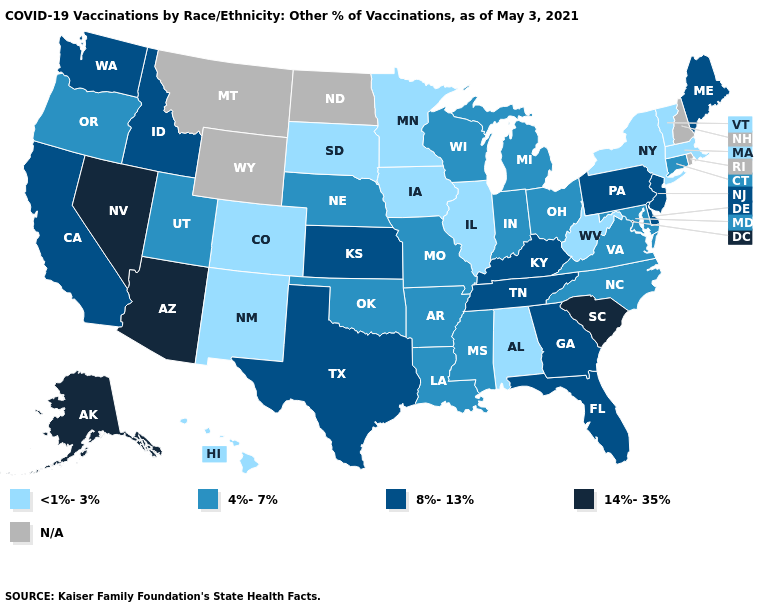Name the states that have a value in the range 14%-35%?
Give a very brief answer. Alaska, Arizona, Nevada, South Carolina. Does the first symbol in the legend represent the smallest category?
Give a very brief answer. Yes. Among the states that border Florida , does Georgia have the highest value?
Concise answer only. Yes. What is the value of Idaho?
Be succinct. 8%-13%. What is the value of Wisconsin?
Answer briefly. 4%-7%. Does Missouri have the highest value in the MidWest?
Concise answer only. No. What is the highest value in the USA?
Keep it brief. 14%-35%. What is the value of Kansas?
Be succinct. 8%-13%. Name the states that have a value in the range 14%-35%?
Answer briefly. Alaska, Arizona, Nevada, South Carolina. Does Alabama have the lowest value in the South?
Concise answer only. Yes. What is the lowest value in the Northeast?
Answer briefly. <1%-3%. What is the lowest value in the West?
Answer briefly. <1%-3%. How many symbols are there in the legend?
Give a very brief answer. 5. 